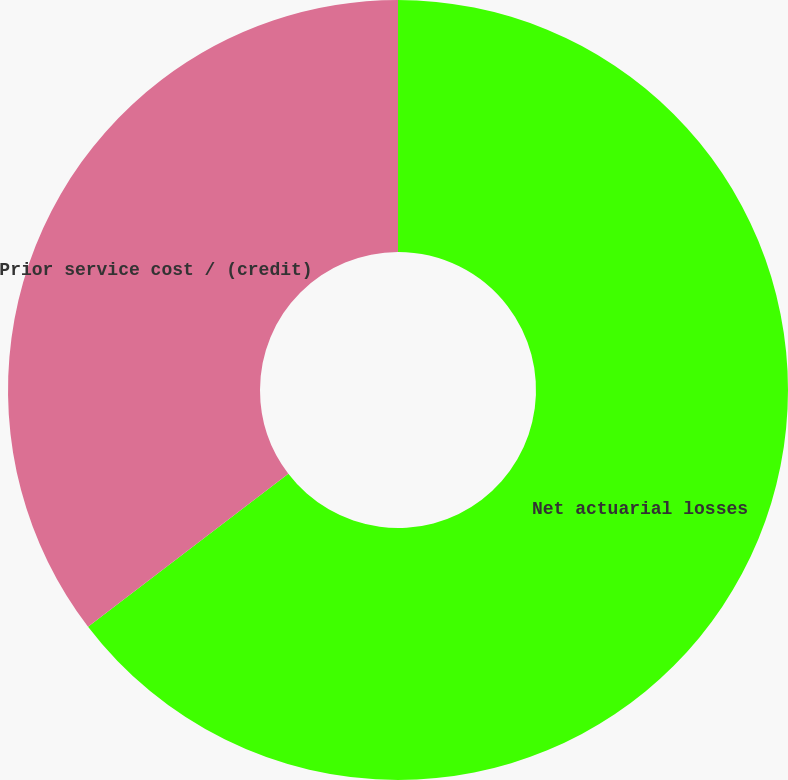Convert chart to OTSL. <chart><loc_0><loc_0><loc_500><loc_500><pie_chart><fcel>Net actuarial losses<fcel>Prior service cost / (credit)<nl><fcel>64.62%<fcel>35.38%<nl></chart> 